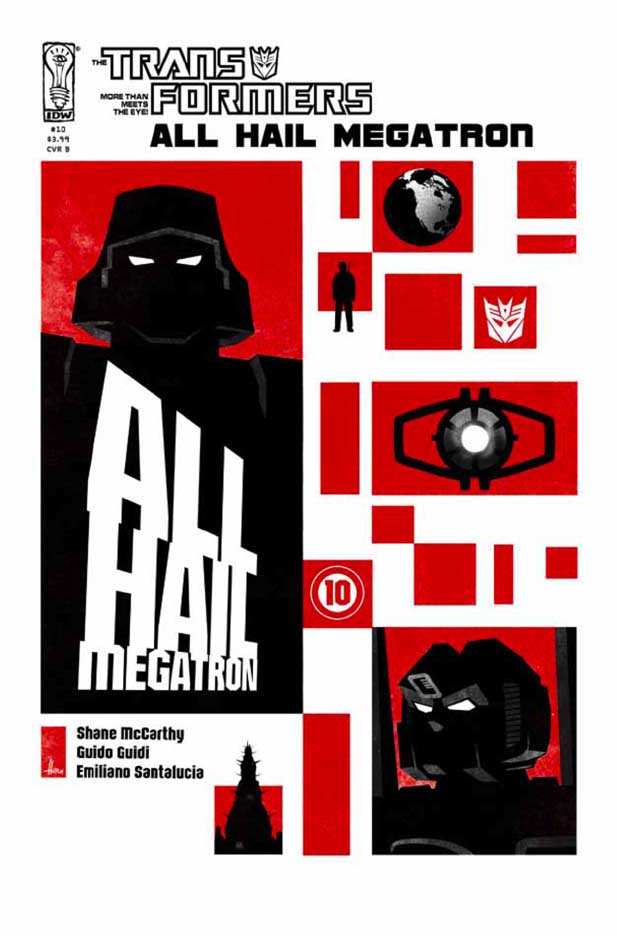If you could step into the scene depicted on the comic cover, what might you hear or feel? Entering the scene on the comic cover, you might be enveloped in an intense atmosphere filled with the sounds of machinery clashing, engines roaring, and the ominous, commanding voice of Megatron declaring his supremacy. The air might feel charged with tension and anticipation, as if standing on the precipice of a massive conflict. The stark contrast of the visuals could evoke a sense of foreboding, with the red symbolizing imminent danger and the black heralding the oppressive presence of Megatron's tyranny. 